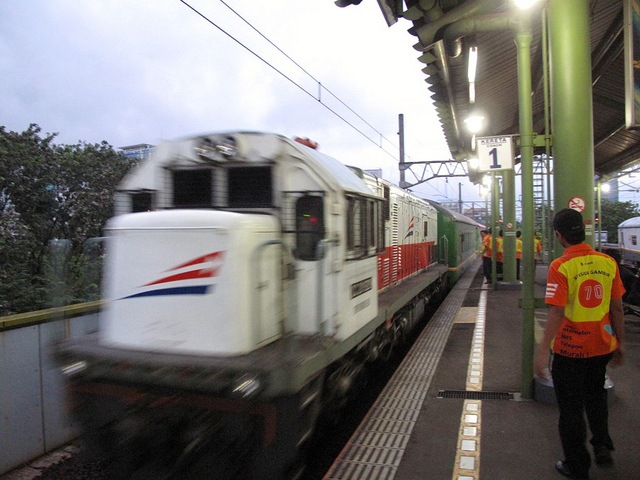Read all the text in this image. 1 